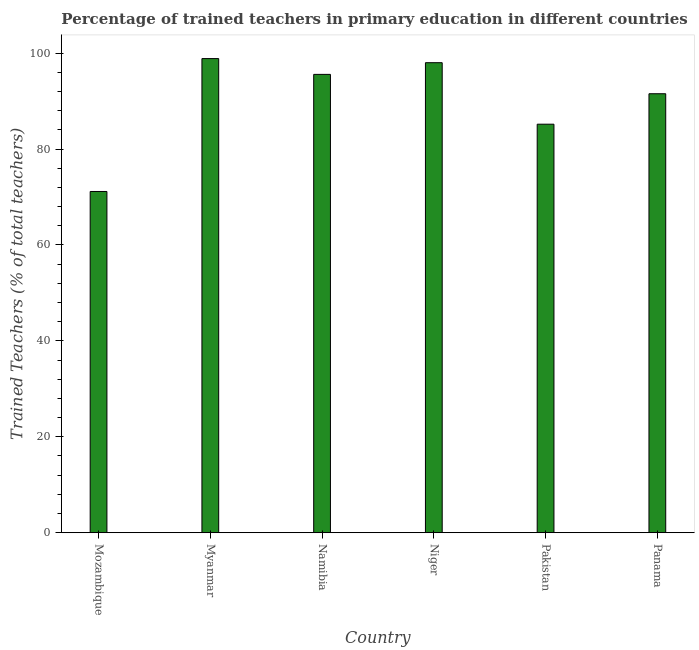Does the graph contain any zero values?
Offer a very short reply. No. Does the graph contain grids?
Offer a terse response. No. What is the title of the graph?
Keep it short and to the point. Percentage of trained teachers in primary education in different countries. What is the label or title of the Y-axis?
Offer a terse response. Trained Teachers (% of total teachers). What is the percentage of trained teachers in Myanmar?
Your answer should be very brief. 98.87. Across all countries, what is the maximum percentage of trained teachers?
Offer a terse response. 98.87. Across all countries, what is the minimum percentage of trained teachers?
Ensure brevity in your answer.  71.16. In which country was the percentage of trained teachers maximum?
Ensure brevity in your answer.  Myanmar. In which country was the percentage of trained teachers minimum?
Your answer should be compact. Mozambique. What is the sum of the percentage of trained teachers?
Your answer should be very brief. 540.34. What is the difference between the percentage of trained teachers in Namibia and Pakistan?
Offer a terse response. 10.39. What is the average percentage of trained teachers per country?
Your response must be concise. 90.06. What is the median percentage of trained teachers?
Ensure brevity in your answer.  93.56. In how many countries, is the percentage of trained teachers greater than 8 %?
Your response must be concise. 6. What is the ratio of the percentage of trained teachers in Namibia to that in Panama?
Offer a very short reply. 1.04. Is the percentage of trained teachers in Pakistan less than that in Panama?
Give a very brief answer. Yes. Is the difference between the percentage of trained teachers in Mozambique and Panama greater than the difference between any two countries?
Provide a succinct answer. No. What is the difference between the highest and the second highest percentage of trained teachers?
Your answer should be compact. 0.86. Is the sum of the percentage of trained teachers in Mozambique and Namibia greater than the maximum percentage of trained teachers across all countries?
Give a very brief answer. Yes. What is the difference between the highest and the lowest percentage of trained teachers?
Offer a very short reply. 27.71. Are all the bars in the graph horizontal?
Your response must be concise. No. How many countries are there in the graph?
Provide a short and direct response. 6. Are the values on the major ticks of Y-axis written in scientific E-notation?
Offer a terse response. No. What is the Trained Teachers (% of total teachers) in Mozambique?
Provide a short and direct response. 71.16. What is the Trained Teachers (% of total teachers) of Myanmar?
Give a very brief answer. 98.87. What is the Trained Teachers (% of total teachers) of Namibia?
Provide a succinct answer. 95.58. What is the Trained Teachers (% of total teachers) of Niger?
Ensure brevity in your answer.  98.01. What is the Trained Teachers (% of total teachers) in Pakistan?
Your response must be concise. 85.19. What is the Trained Teachers (% of total teachers) of Panama?
Keep it short and to the point. 91.54. What is the difference between the Trained Teachers (% of total teachers) in Mozambique and Myanmar?
Provide a succinct answer. -27.71. What is the difference between the Trained Teachers (% of total teachers) in Mozambique and Namibia?
Offer a very short reply. -24.42. What is the difference between the Trained Teachers (% of total teachers) in Mozambique and Niger?
Provide a succinct answer. -26.86. What is the difference between the Trained Teachers (% of total teachers) in Mozambique and Pakistan?
Provide a succinct answer. -14.03. What is the difference between the Trained Teachers (% of total teachers) in Mozambique and Panama?
Your response must be concise. -20.38. What is the difference between the Trained Teachers (% of total teachers) in Myanmar and Namibia?
Your answer should be very brief. 3.29. What is the difference between the Trained Teachers (% of total teachers) in Myanmar and Niger?
Your answer should be very brief. 0.86. What is the difference between the Trained Teachers (% of total teachers) in Myanmar and Pakistan?
Offer a terse response. 13.68. What is the difference between the Trained Teachers (% of total teachers) in Myanmar and Panama?
Give a very brief answer. 7.33. What is the difference between the Trained Teachers (% of total teachers) in Namibia and Niger?
Ensure brevity in your answer.  -2.44. What is the difference between the Trained Teachers (% of total teachers) in Namibia and Pakistan?
Your answer should be very brief. 10.39. What is the difference between the Trained Teachers (% of total teachers) in Namibia and Panama?
Provide a short and direct response. 4.04. What is the difference between the Trained Teachers (% of total teachers) in Niger and Pakistan?
Offer a terse response. 12.83. What is the difference between the Trained Teachers (% of total teachers) in Niger and Panama?
Your answer should be compact. 6.47. What is the difference between the Trained Teachers (% of total teachers) in Pakistan and Panama?
Give a very brief answer. -6.35. What is the ratio of the Trained Teachers (% of total teachers) in Mozambique to that in Myanmar?
Ensure brevity in your answer.  0.72. What is the ratio of the Trained Teachers (% of total teachers) in Mozambique to that in Namibia?
Provide a short and direct response. 0.74. What is the ratio of the Trained Teachers (% of total teachers) in Mozambique to that in Niger?
Your response must be concise. 0.73. What is the ratio of the Trained Teachers (% of total teachers) in Mozambique to that in Pakistan?
Ensure brevity in your answer.  0.83. What is the ratio of the Trained Teachers (% of total teachers) in Mozambique to that in Panama?
Provide a succinct answer. 0.78. What is the ratio of the Trained Teachers (% of total teachers) in Myanmar to that in Namibia?
Your response must be concise. 1.03. What is the ratio of the Trained Teachers (% of total teachers) in Myanmar to that in Pakistan?
Your response must be concise. 1.16. What is the ratio of the Trained Teachers (% of total teachers) in Namibia to that in Pakistan?
Give a very brief answer. 1.12. What is the ratio of the Trained Teachers (% of total teachers) in Namibia to that in Panama?
Make the answer very short. 1.04. What is the ratio of the Trained Teachers (% of total teachers) in Niger to that in Pakistan?
Ensure brevity in your answer.  1.15. What is the ratio of the Trained Teachers (% of total teachers) in Niger to that in Panama?
Provide a succinct answer. 1.07. What is the ratio of the Trained Teachers (% of total teachers) in Pakistan to that in Panama?
Your answer should be very brief. 0.93. 